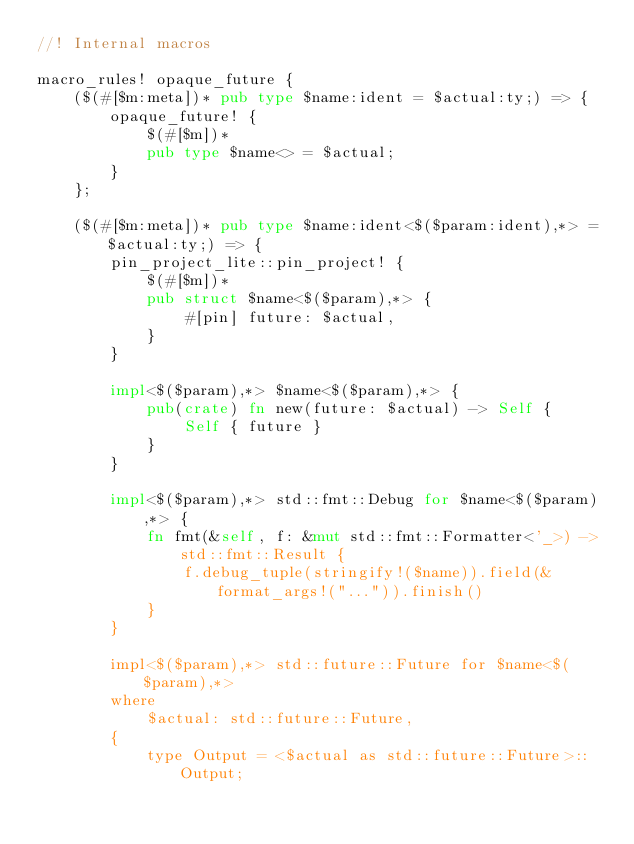Convert code to text. <code><loc_0><loc_0><loc_500><loc_500><_Rust_>//! Internal macros

macro_rules! opaque_future {
    ($(#[$m:meta])* pub type $name:ident = $actual:ty;) => {
        opaque_future! {
            $(#[$m])*
            pub type $name<> = $actual;
        }
    };

    ($(#[$m:meta])* pub type $name:ident<$($param:ident),*> = $actual:ty;) => {
        pin_project_lite::pin_project! {
            $(#[$m])*
            pub struct $name<$($param),*> {
                #[pin] future: $actual,
            }
        }

        impl<$($param),*> $name<$($param),*> {
            pub(crate) fn new(future: $actual) -> Self {
                Self { future }
            }
        }

        impl<$($param),*> std::fmt::Debug for $name<$($param),*> {
            fn fmt(&self, f: &mut std::fmt::Formatter<'_>) -> std::fmt::Result {
                f.debug_tuple(stringify!($name)).field(&format_args!("...")).finish()
            }
        }

        impl<$($param),*> std::future::Future for $name<$($param),*>
        where
            $actual: std::future::Future,
        {
            type Output = <$actual as std::future::Future>::Output;
</code> 